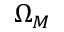Convert formula to latex. <formula><loc_0><loc_0><loc_500><loc_500>\Omega _ { M }</formula> 